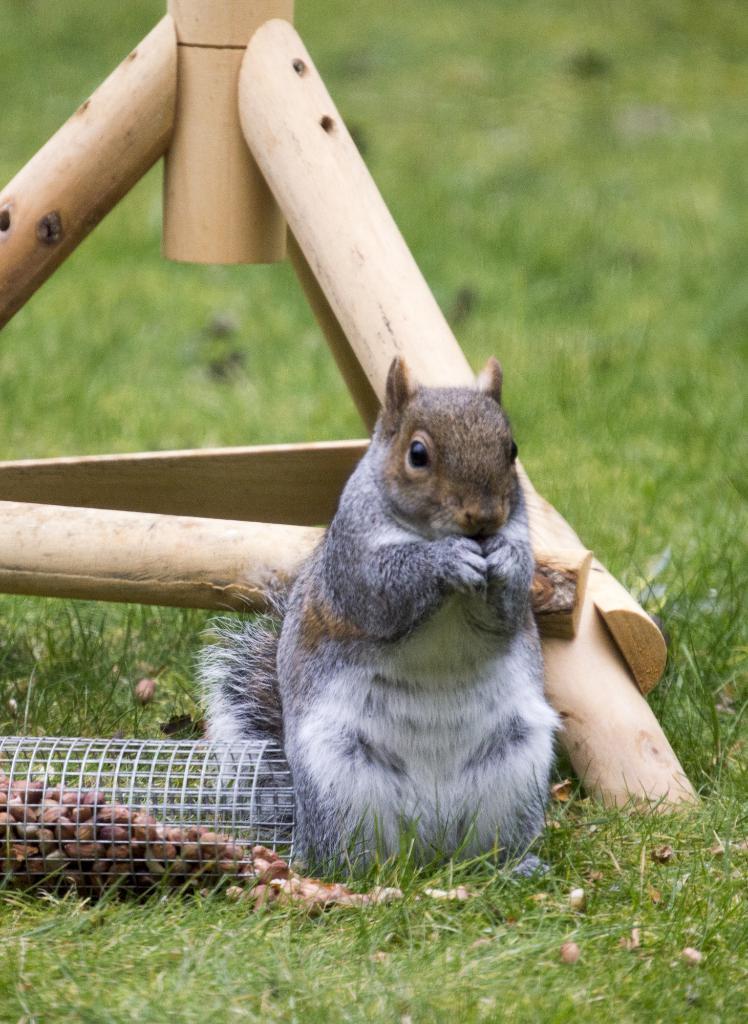Can you describe this image briefly? Here we can see a squirrel standing on the grass and on the left there are nuts in a welded wire mesh. In the background we can see wooden object and grass. 